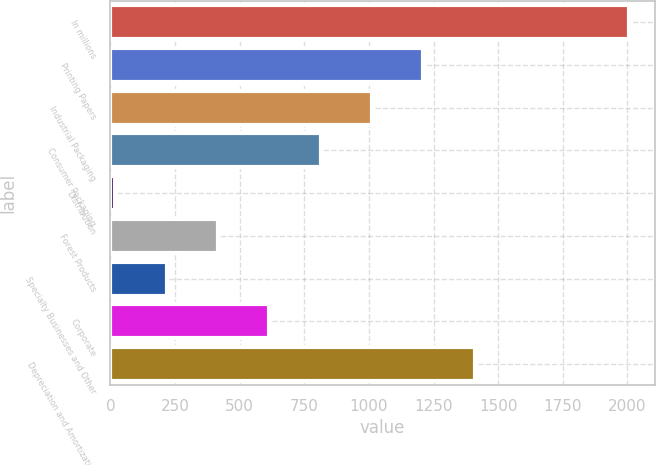Convert chart. <chart><loc_0><loc_0><loc_500><loc_500><bar_chart><fcel>In millions<fcel>Printing Papers<fcel>Industrial Packaging<fcel>Consumer Packaging<fcel>Distribution<fcel>Forest Products<fcel>Specialty Businesses and Other<fcel>Corporate<fcel>Depreciation and Amortization<nl><fcel>2005<fcel>1210.6<fcel>1012<fcel>813.4<fcel>19<fcel>416.2<fcel>217.6<fcel>614.8<fcel>1409.2<nl></chart> 